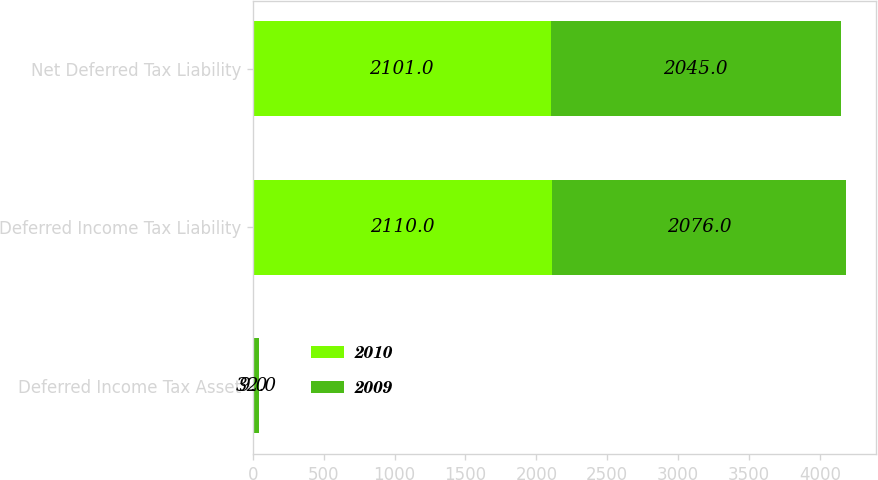Convert chart. <chart><loc_0><loc_0><loc_500><loc_500><stacked_bar_chart><ecel><fcel>Deferred Income Tax Asset<fcel>Deferred Income Tax Liability<fcel>Net Deferred Tax Liability<nl><fcel>2010<fcel>9<fcel>2110<fcel>2101<nl><fcel>2009<fcel>32<fcel>2076<fcel>2045<nl></chart> 